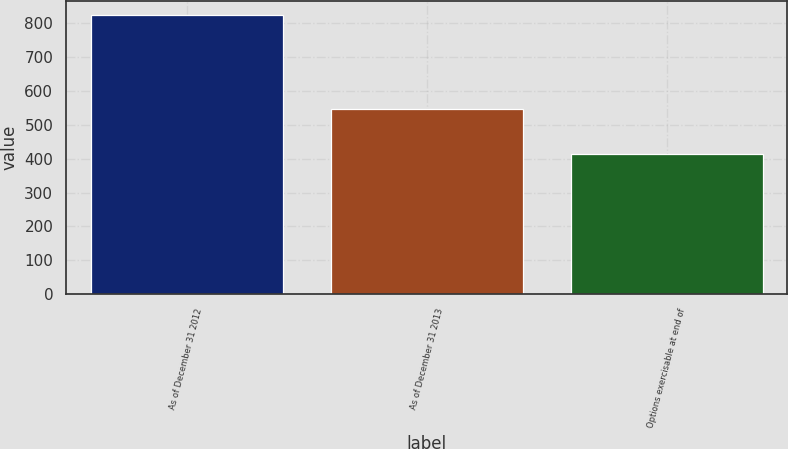Convert chart. <chart><loc_0><loc_0><loc_500><loc_500><bar_chart><fcel>As of December 31 2012<fcel>As of December 31 2013<fcel>Options exercisable at end of<nl><fcel>823<fcel>547<fcel>415<nl></chart> 